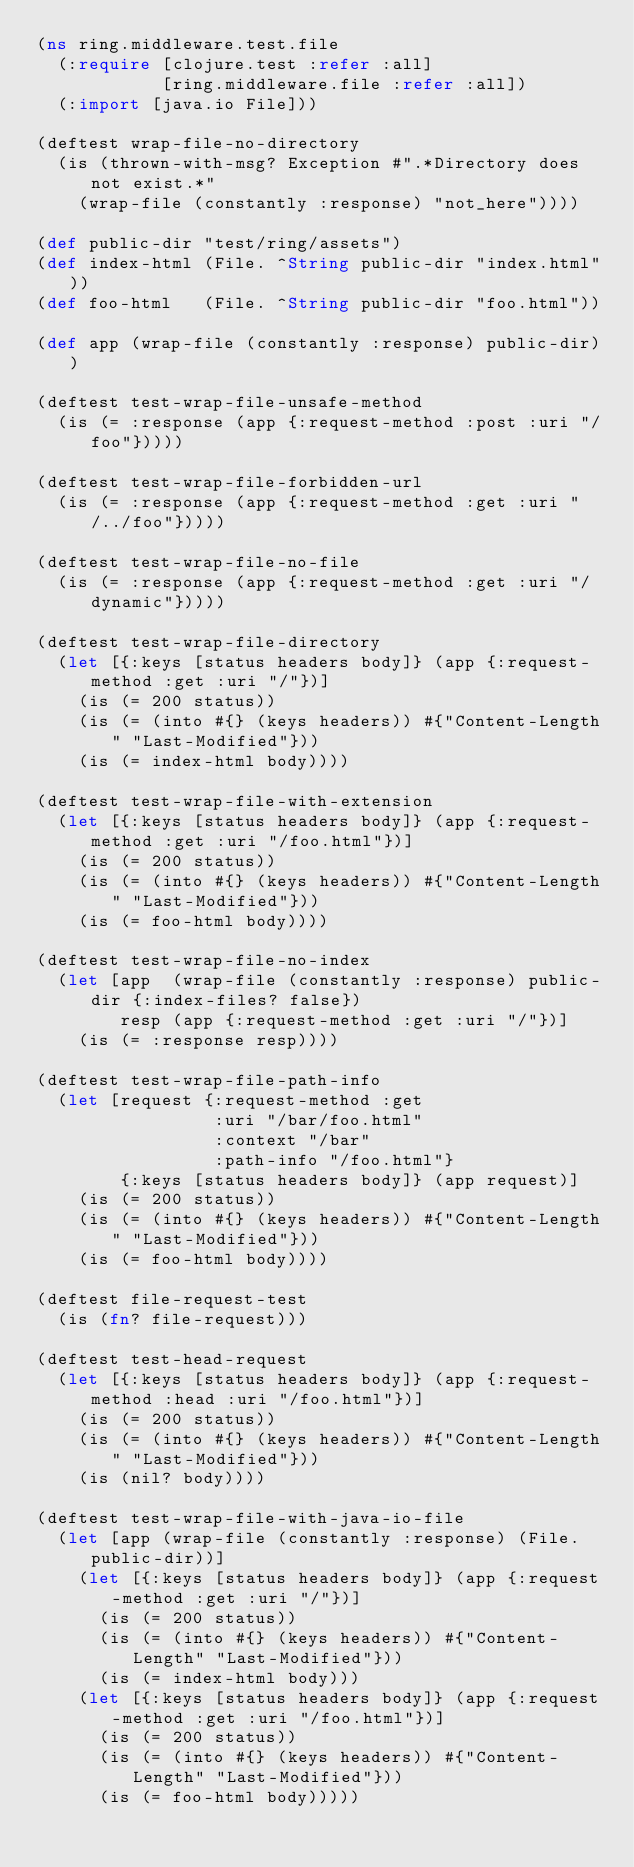Convert code to text. <code><loc_0><loc_0><loc_500><loc_500><_Clojure_>(ns ring.middleware.test.file
  (:require [clojure.test :refer :all]
            [ring.middleware.file :refer :all])
  (:import [java.io File]))

(deftest wrap-file-no-directory
  (is (thrown-with-msg? Exception #".*Directory does not exist.*"
    (wrap-file (constantly :response) "not_here"))))

(def public-dir "test/ring/assets")
(def index-html (File. ^String public-dir "index.html"))
(def foo-html   (File. ^String public-dir "foo.html"))

(def app (wrap-file (constantly :response) public-dir))

(deftest test-wrap-file-unsafe-method
  (is (= :response (app {:request-method :post :uri "/foo"}))))

(deftest test-wrap-file-forbidden-url
  (is (= :response (app {:request-method :get :uri "/../foo"}))))

(deftest test-wrap-file-no-file
  (is (= :response (app {:request-method :get :uri "/dynamic"}))))

(deftest test-wrap-file-directory
  (let [{:keys [status headers body]} (app {:request-method :get :uri "/"})]
    (is (= 200 status))
    (is (= (into #{} (keys headers)) #{"Content-Length" "Last-Modified"}))
    (is (= index-html body))))

(deftest test-wrap-file-with-extension
  (let [{:keys [status headers body]} (app {:request-method :get :uri "/foo.html"})]
    (is (= 200 status))
    (is (= (into #{} (keys headers)) #{"Content-Length" "Last-Modified"}))
    (is (= foo-html body))))

(deftest test-wrap-file-no-index
  (let [app  (wrap-file (constantly :response) public-dir {:index-files? false})
        resp (app {:request-method :get :uri "/"})]
    (is (= :response resp))))

(deftest test-wrap-file-path-info
  (let [request {:request-method :get
                 :uri "/bar/foo.html"
                 :context "/bar"
                 :path-info "/foo.html"}
        {:keys [status headers body]} (app request)]
    (is (= 200 status))
    (is (= (into #{} (keys headers)) #{"Content-Length" "Last-Modified"}))
    (is (= foo-html body))))

(deftest file-request-test
  (is (fn? file-request)))

(deftest test-head-request
  (let [{:keys [status headers body]} (app {:request-method :head :uri "/foo.html"})]
    (is (= 200 status))
    (is (= (into #{} (keys headers)) #{"Content-Length" "Last-Modified"}))
    (is (nil? body))))

(deftest test-wrap-file-with-java-io-file
  (let [app (wrap-file (constantly :response) (File. public-dir))]
    (let [{:keys [status headers body]} (app {:request-method :get :uri "/"})]
      (is (= 200 status))
      (is (= (into #{} (keys headers)) #{"Content-Length" "Last-Modified"}))
      (is (= index-html body)))
    (let [{:keys [status headers body]} (app {:request-method :get :uri "/foo.html"})]
      (is (= 200 status))
      (is (= (into #{} (keys headers)) #{"Content-Length" "Last-Modified"}))
      (is (= foo-html body)))))
</code> 